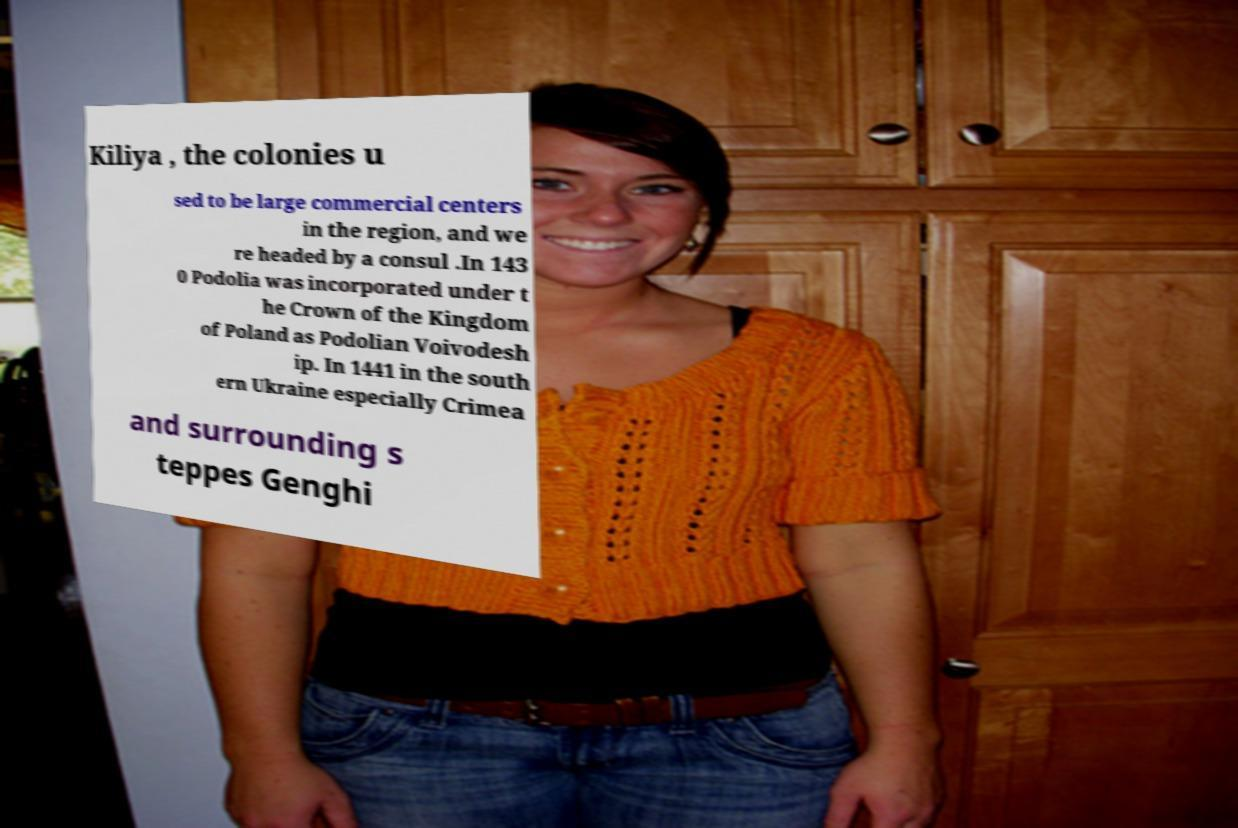What messages or text are displayed in this image? I need them in a readable, typed format. Kiliya , the colonies u sed to be large commercial centers in the region, and we re headed by a consul .In 143 0 Podolia was incorporated under t he Crown of the Kingdom of Poland as Podolian Voivodesh ip. In 1441 in the south ern Ukraine especially Crimea and surrounding s teppes Genghi 